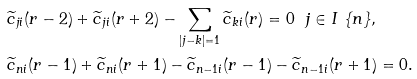<formula> <loc_0><loc_0><loc_500><loc_500>& \widetilde { c } _ { j i } ( r - 2 ) + \widetilde { c } _ { j i } ( r + 2 ) - \sum _ { | j - k | = 1 } \widetilde { c } _ { k i } ( r ) = 0 \ \ j \in I \ \{ n \} , \\ & \widetilde { c } _ { n i } ( r - 1 ) + \widetilde { c } _ { n i } ( r + 1 ) - \widetilde { c } _ { n - 1 i } ( r - 1 ) - \widetilde { c } _ { n - 1 i } ( r + 1 ) = 0 .</formula> 